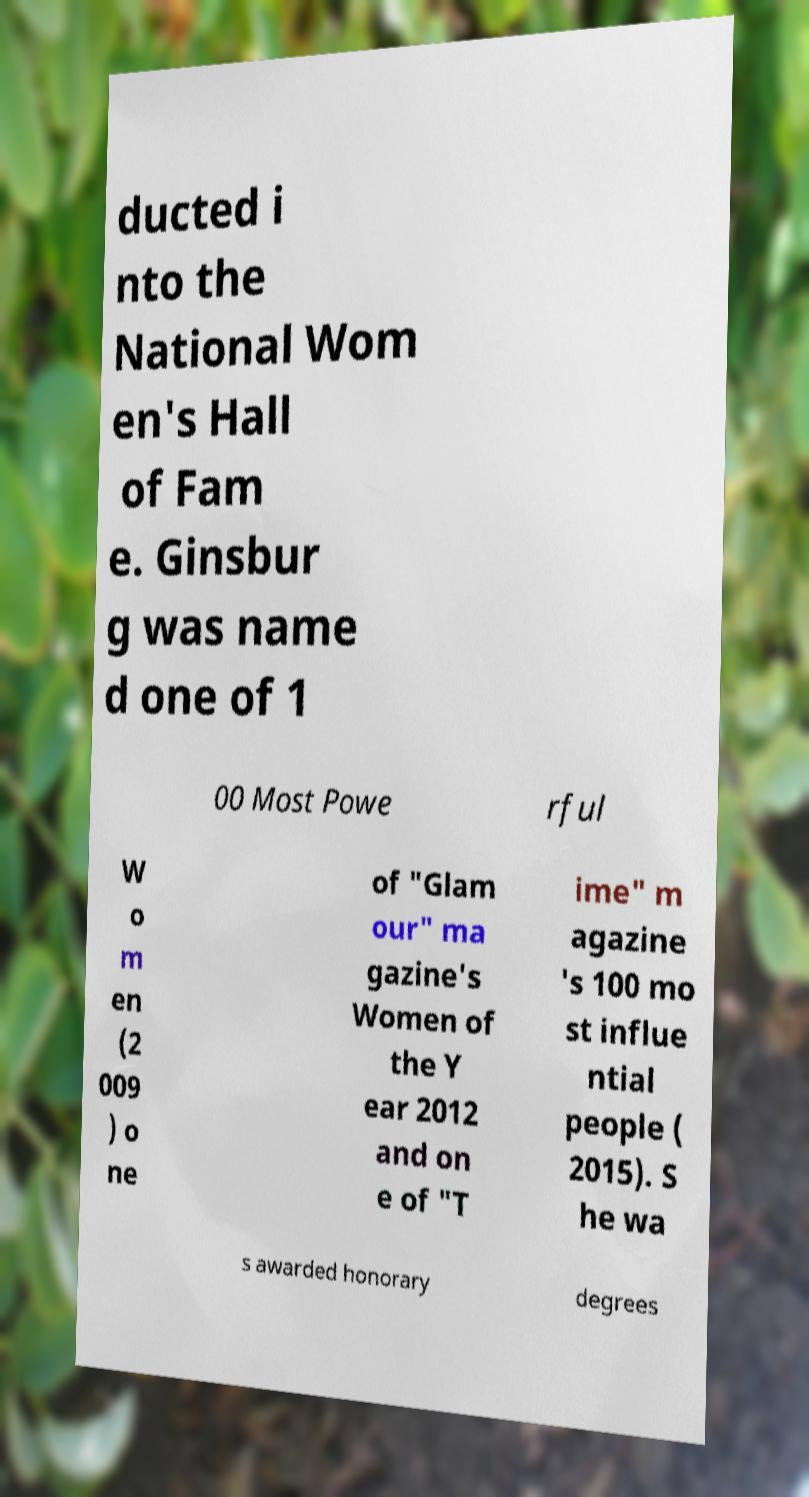There's text embedded in this image that I need extracted. Can you transcribe it verbatim? ducted i nto the National Wom en's Hall of Fam e. Ginsbur g was name d one of 1 00 Most Powe rful W o m en (2 009 ) o ne of "Glam our" ma gazine's Women of the Y ear 2012 and on e of "T ime" m agazine 's 100 mo st influe ntial people ( 2015). S he wa s awarded honorary degrees 